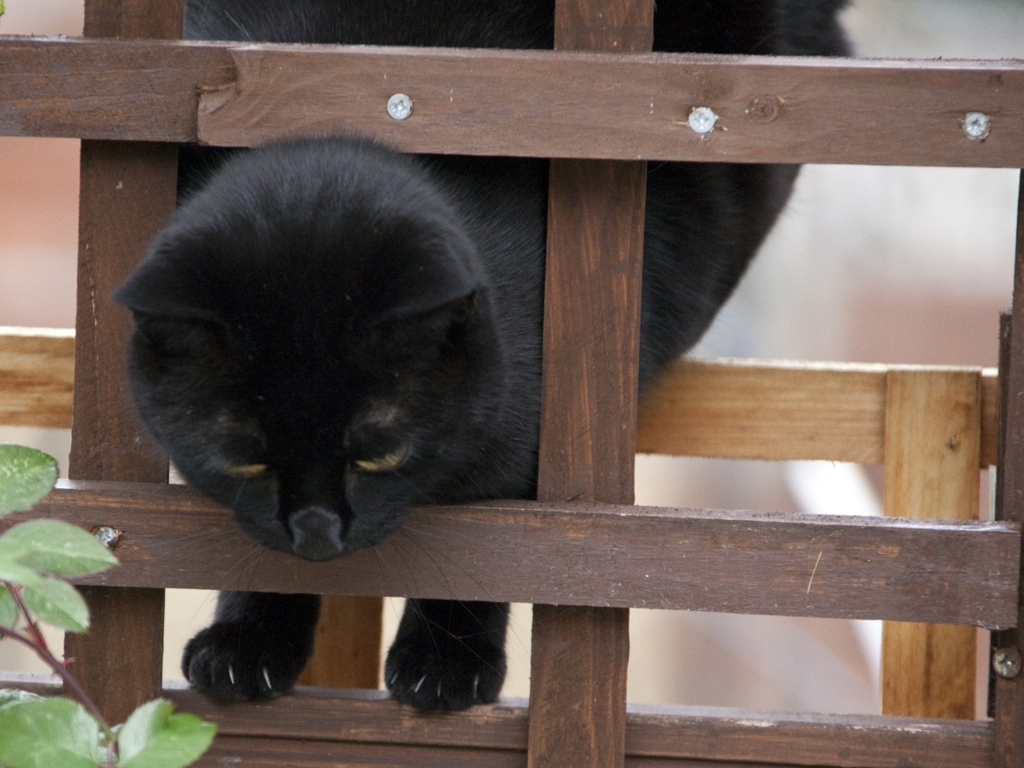What might be the story behind this image or what do you think the cat is doing? This image could represent a moment of playful or inquisitive exploration. The cat may be observing something of interest outside the frame or considering an attempt to navigate through or around the lattice. The way it's positioned, with its paws delicately balanced on the wooden slats, suggests careful, deliberate movement, possibly hinting at the whimsical nature of feline behavior. 